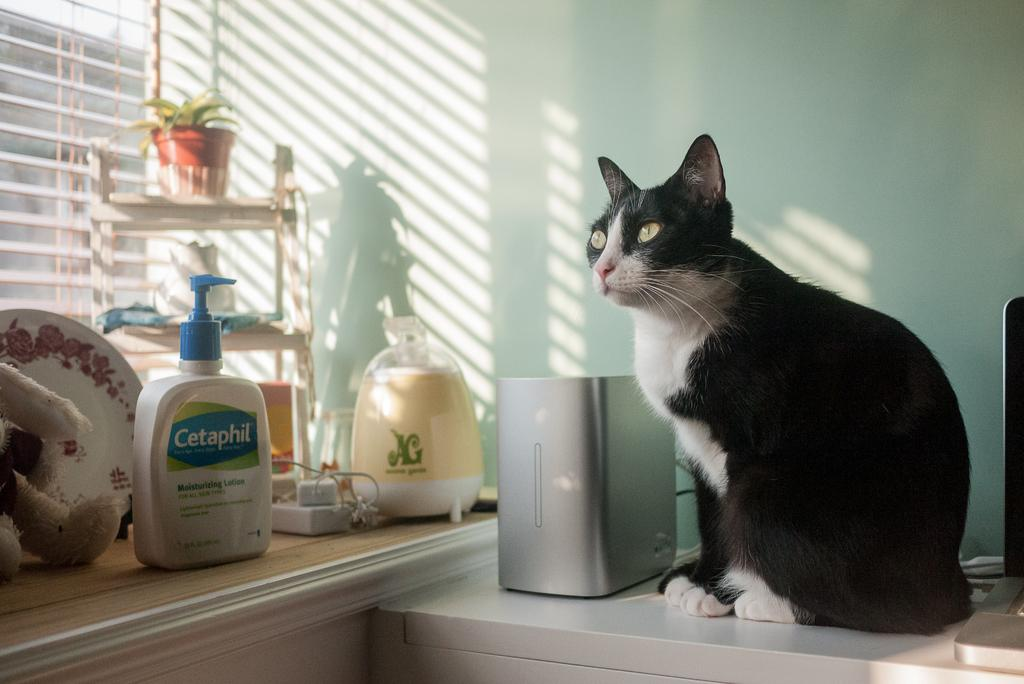What type of living creature is in the image? There is an animal in the image. What is located beside the animal? There is an object beside the animal. What can be seen on the left side of the image? There are objects on a desk on the left side of the image. What type of vegetation is in the image? There is a plant in the image. What architectural feature is visible in the image? There is a window in the image. What type of surface is visible in the image? There is a wall visible in the image. What type of coach can be seen in the image? There is no coach present in the image. What type of songs is the animal singing in the image? There is no indication that the animal is singing in the image. 